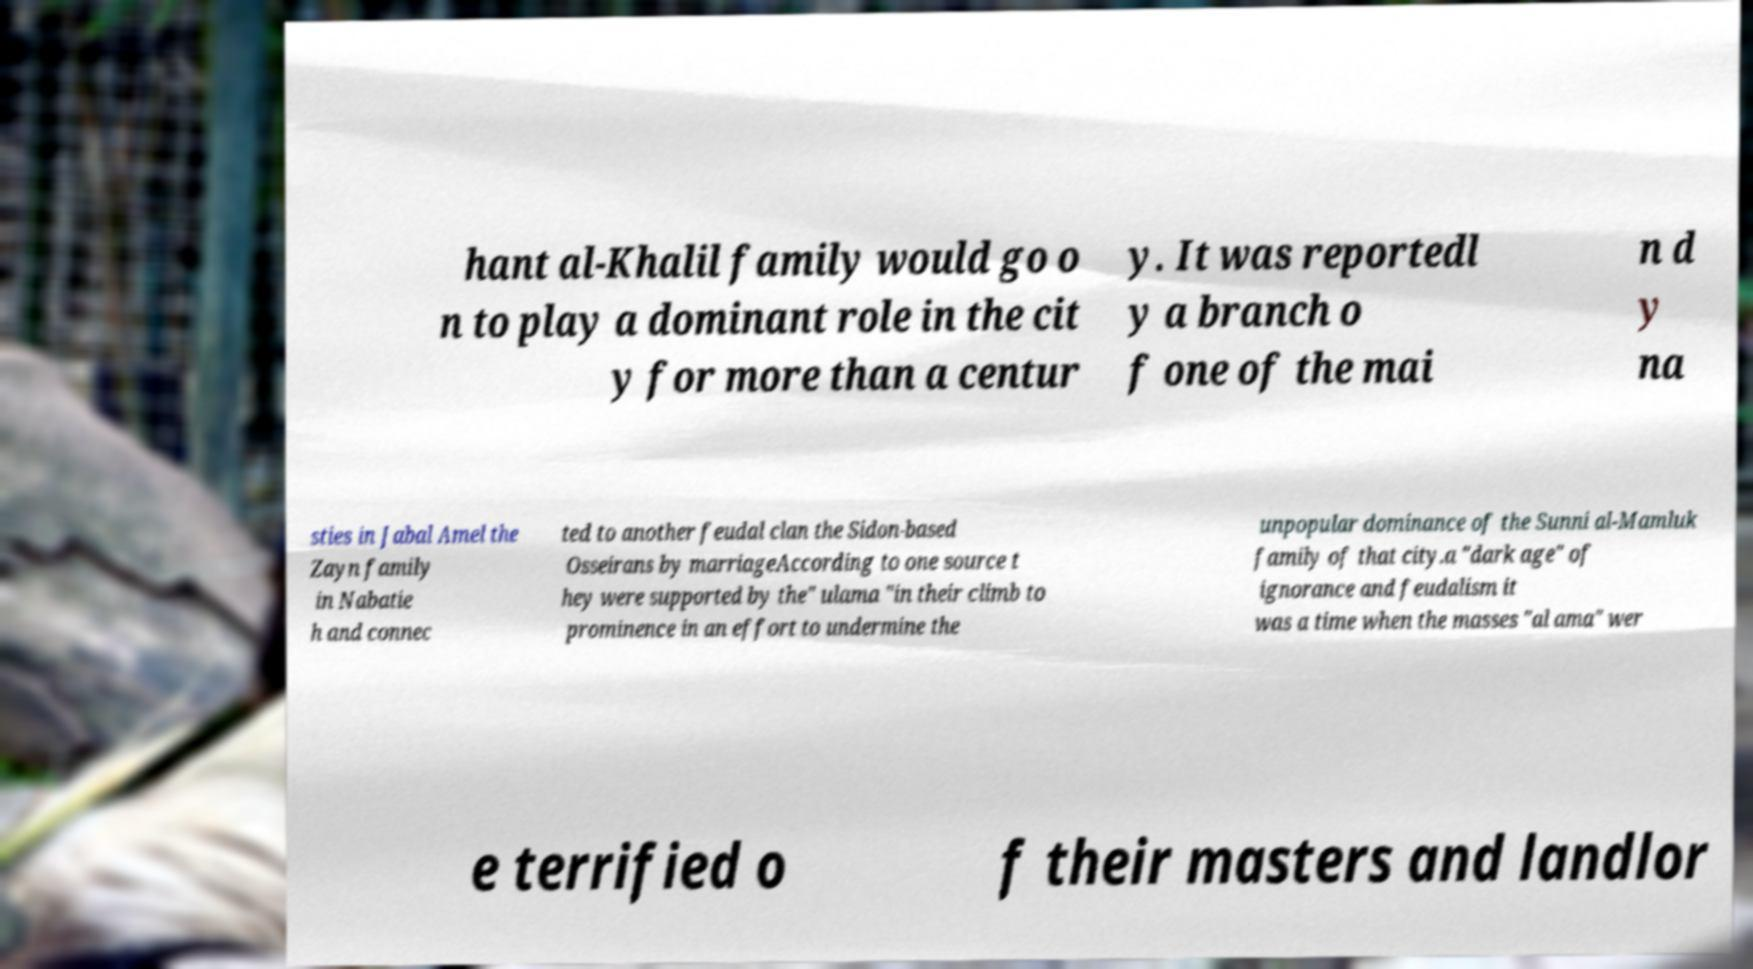There's text embedded in this image that I need extracted. Can you transcribe it verbatim? hant al-Khalil family would go o n to play a dominant role in the cit y for more than a centur y. It was reportedl y a branch o f one of the mai n d y na sties in Jabal Amel the Zayn family in Nabatie h and connec ted to another feudal clan the Sidon-based Osseirans by marriageAccording to one source t hey were supported by the" ulama "in their climb to prominence in an effort to undermine the unpopular dominance of the Sunni al-Mamluk family of that city.a "dark age" of ignorance and feudalism it was a time when the masses "al ama" wer e terrified o f their masters and landlor 